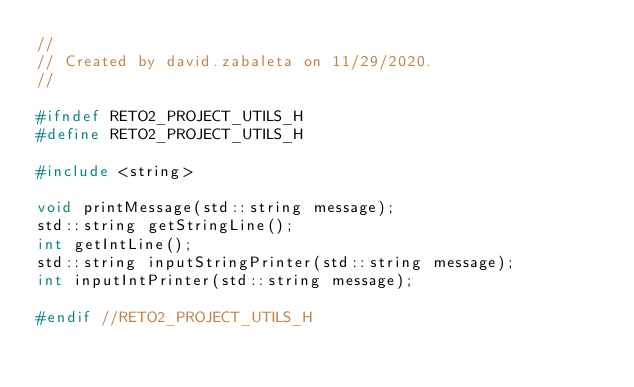Convert code to text. <code><loc_0><loc_0><loc_500><loc_500><_C_>//
// Created by david.zabaleta on 11/29/2020.
//

#ifndef RETO2_PROJECT_UTILS_H
#define RETO2_PROJECT_UTILS_H

#include <string>

void printMessage(std::string message);
std::string getStringLine();
int getIntLine();
std::string inputStringPrinter(std::string message);
int inputIntPrinter(std::string message);

#endif //RETO2_PROJECT_UTILS_H
</code> 